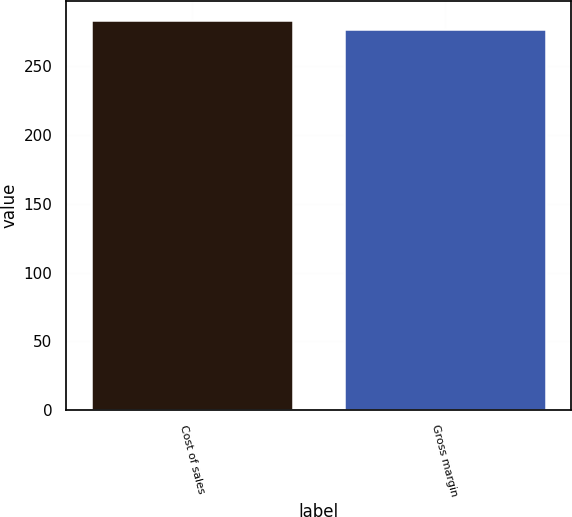Convert chart to OTSL. <chart><loc_0><loc_0><loc_500><loc_500><bar_chart><fcel>Cost of sales<fcel>Gross margin<nl><fcel>283<fcel>277<nl></chart> 